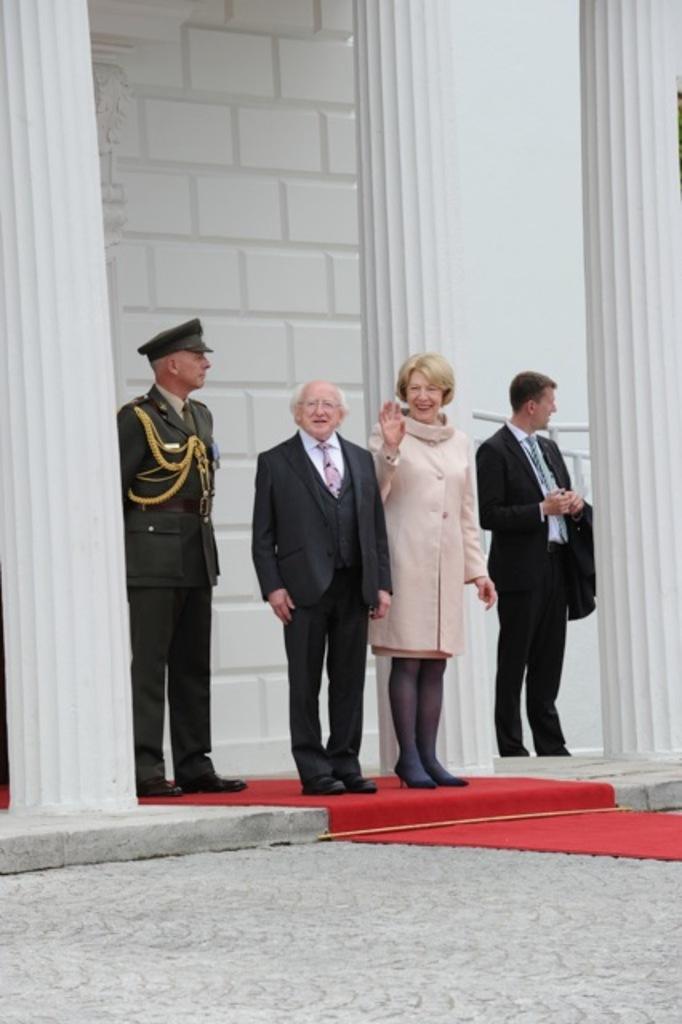Describe this image in one or two sentences. In this image we can see people standing. The man standing on the left is wearing a uniform. At the bottom there is a red carpet. In the background there is a building. 